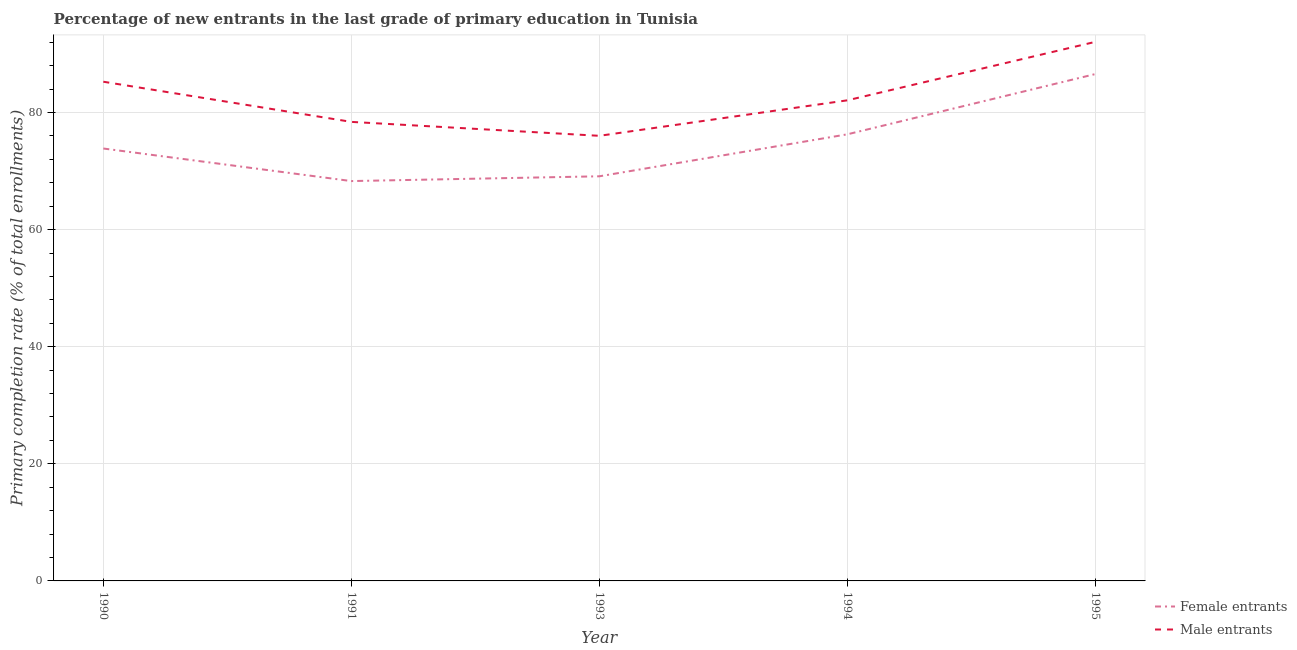Does the line corresponding to primary completion rate of female entrants intersect with the line corresponding to primary completion rate of male entrants?
Ensure brevity in your answer.  No. What is the primary completion rate of female entrants in 1993?
Offer a very short reply. 69.1. Across all years, what is the maximum primary completion rate of male entrants?
Make the answer very short. 92.07. Across all years, what is the minimum primary completion rate of female entrants?
Your response must be concise. 68.29. In which year was the primary completion rate of male entrants maximum?
Make the answer very short. 1995. In which year was the primary completion rate of female entrants minimum?
Your answer should be compact. 1991. What is the total primary completion rate of male entrants in the graph?
Provide a short and direct response. 413.82. What is the difference between the primary completion rate of female entrants in 1993 and that in 1994?
Give a very brief answer. -7.17. What is the difference between the primary completion rate of female entrants in 1994 and the primary completion rate of male entrants in 1995?
Your answer should be compact. -15.79. What is the average primary completion rate of female entrants per year?
Provide a short and direct response. 74.82. In the year 1990, what is the difference between the primary completion rate of female entrants and primary completion rate of male entrants?
Your response must be concise. -11.41. What is the ratio of the primary completion rate of female entrants in 1990 to that in 1994?
Ensure brevity in your answer.  0.97. Is the primary completion rate of male entrants in 1991 less than that in 1994?
Offer a very short reply. Yes. What is the difference between the highest and the second highest primary completion rate of female entrants?
Your answer should be compact. 10.29. What is the difference between the highest and the lowest primary completion rate of female entrants?
Provide a short and direct response. 18.28. In how many years, is the primary completion rate of female entrants greater than the average primary completion rate of female entrants taken over all years?
Your answer should be compact. 2. Is the primary completion rate of male entrants strictly greater than the primary completion rate of female entrants over the years?
Offer a terse response. Yes. Is the primary completion rate of male entrants strictly less than the primary completion rate of female entrants over the years?
Provide a succinct answer. No. How many lines are there?
Provide a short and direct response. 2. How many years are there in the graph?
Provide a succinct answer. 5. What is the difference between two consecutive major ticks on the Y-axis?
Ensure brevity in your answer.  20. Are the values on the major ticks of Y-axis written in scientific E-notation?
Your response must be concise. No. Does the graph contain any zero values?
Offer a very short reply. No. Where does the legend appear in the graph?
Your answer should be very brief. Bottom right. How are the legend labels stacked?
Your answer should be very brief. Vertical. What is the title of the graph?
Keep it short and to the point. Percentage of new entrants in the last grade of primary education in Tunisia. Does "Crop" appear as one of the legend labels in the graph?
Ensure brevity in your answer.  No. What is the label or title of the X-axis?
Your answer should be compact. Year. What is the label or title of the Y-axis?
Provide a succinct answer. Primary completion rate (% of total enrollments). What is the Primary completion rate (% of total enrollments) of Female entrants in 1990?
Keep it short and to the point. 73.85. What is the Primary completion rate (% of total enrollments) in Male entrants in 1990?
Keep it short and to the point. 85.26. What is the Primary completion rate (% of total enrollments) in Female entrants in 1991?
Offer a terse response. 68.29. What is the Primary completion rate (% of total enrollments) in Male entrants in 1991?
Offer a terse response. 78.4. What is the Primary completion rate (% of total enrollments) in Female entrants in 1993?
Give a very brief answer. 69.1. What is the Primary completion rate (% of total enrollments) of Male entrants in 1993?
Provide a short and direct response. 76.02. What is the Primary completion rate (% of total enrollments) in Female entrants in 1994?
Your answer should be very brief. 76.27. What is the Primary completion rate (% of total enrollments) in Male entrants in 1994?
Your response must be concise. 82.08. What is the Primary completion rate (% of total enrollments) of Female entrants in 1995?
Offer a very short reply. 86.57. What is the Primary completion rate (% of total enrollments) of Male entrants in 1995?
Your answer should be compact. 92.07. Across all years, what is the maximum Primary completion rate (% of total enrollments) in Female entrants?
Provide a succinct answer. 86.57. Across all years, what is the maximum Primary completion rate (% of total enrollments) of Male entrants?
Offer a terse response. 92.07. Across all years, what is the minimum Primary completion rate (% of total enrollments) in Female entrants?
Offer a very short reply. 68.29. Across all years, what is the minimum Primary completion rate (% of total enrollments) of Male entrants?
Offer a very short reply. 76.02. What is the total Primary completion rate (% of total enrollments) of Female entrants in the graph?
Your answer should be compact. 374.09. What is the total Primary completion rate (% of total enrollments) in Male entrants in the graph?
Offer a very short reply. 413.82. What is the difference between the Primary completion rate (% of total enrollments) of Female entrants in 1990 and that in 1991?
Make the answer very short. 5.56. What is the difference between the Primary completion rate (% of total enrollments) of Male entrants in 1990 and that in 1991?
Offer a very short reply. 6.86. What is the difference between the Primary completion rate (% of total enrollments) of Female entrants in 1990 and that in 1993?
Give a very brief answer. 4.75. What is the difference between the Primary completion rate (% of total enrollments) in Male entrants in 1990 and that in 1993?
Your answer should be compact. 9.24. What is the difference between the Primary completion rate (% of total enrollments) of Female entrants in 1990 and that in 1994?
Provide a succinct answer. -2.42. What is the difference between the Primary completion rate (% of total enrollments) in Male entrants in 1990 and that in 1994?
Make the answer very short. 3.17. What is the difference between the Primary completion rate (% of total enrollments) in Female entrants in 1990 and that in 1995?
Your answer should be compact. -12.72. What is the difference between the Primary completion rate (% of total enrollments) of Male entrants in 1990 and that in 1995?
Your response must be concise. -6.81. What is the difference between the Primary completion rate (% of total enrollments) of Female entrants in 1991 and that in 1993?
Give a very brief answer. -0.82. What is the difference between the Primary completion rate (% of total enrollments) of Male entrants in 1991 and that in 1993?
Ensure brevity in your answer.  2.38. What is the difference between the Primary completion rate (% of total enrollments) in Female entrants in 1991 and that in 1994?
Provide a short and direct response. -7.99. What is the difference between the Primary completion rate (% of total enrollments) in Male entrants in 1991 and that in 1994?
Your answer should be compact. -3.69. What is the difference between the Primary completion rate (% of total enrollments) of Female entrants in 1991 and that in 1995?
Make the answer very short. -18.28. What is the difference between the Primary completion rate (% of total enrollments) of Male entrants in 1991 and that in 1995?
Your response must be concise. -13.67. What is the difference between the Primary completion rate (% of total enrollments) in Female entrants in 1993 and that in 1994?
Offer a terse response. -7.17. What is the difference between the Primary completion rate (% of total enrollments) in Male entrants in 1993 and that in 1994?
Your answer should be compact. -6.06. What is the difference between the Primary completion rate (% of total enrollments) of Female entrants in 1993 and that in 1995?
Provide a succinct answer. -17.46. What is the difference between the Primary completion rate (% of total enrollments) in Male entrants in 1993 and that in 1995?
Your answer should be compact. -16.05. What is the difference between the Primary completion rate (% of total enrollments) in Female entrants in 1994 and that in 1995?
Make the answer very short. -10.29. What is the difference between the Primary completion rate (% of total enrollments) of Male entrants in 1994 and that in 1995?
Provide a succinct answer. -9.99. What is the difference between the Primary completion rate (% of total enrollments) of Female entrants in 1990 and the Primary completion rate (% of total enrollments) of Male entrants in 1991?
Offer a very short reply. -4.55. What is the difference between the Primary completion rate (% of total enrollments) of Female entrants in 1990 and the Primary completion rate (% of total enrollments) of Male entrants in 1993?
Your response must be concise. -2.17. What is the difference between the Primary completion rate (% of total enrollments) in Female entrants in 1990 and the Primary completion rate (% of total enrollments) in Male entrants in 1994?
Your response must be concise. -8.23. What is the difference between the Primary completion rate (% of total enrollments) in Female entrants in 1990 and the Primary completion rate (% of total enrollments) in Male entrants in 1995?
Provide a short and direct response. -18.22. What is the difference between the Primary completion rate (% of total enrollments) in Female entrants in 1991 and the Primary completion rate (% of total enrollments) in Male entrants in 1993?
Provide a succinct answer. -7.73. What is the difference between the Primary completion rate (% of total enrollments) of Female entrants in 1991 and the Primary completion rate (% of total enrollments) of Male entrants in 1994?
Keep it short and to the point. -13.79. What is the difference between the Primary completion rate (% of total enrollments) of Female entrants in 1991 and the Primary completion rate (% of total enrollments) of Male entrants in 1995?
Give a very brief answer. -23.78. What is the difference between the Primary completion rate (% of total enrollments) of Female entrants in 1993 and the Primary completion rate (% of total enrollments) of Male entrants in 1994?
Your answer should be very brief. -12.98. What is the difference between the Primary completion rate (% of total enrollments) in Female entrants in 1993 and the Primary completion rate (% of total enrollments) in Male entrants in 1995?
Give a very brief answer. -22.96. What is the difference between the Primary completion rate (% of total enrollments) of Female entrants in 1994 and the Primary completion rate (% of total enrollments) of Male entrants in 1995?
Make the answer very short. -15.79. What is the average Primary completion rate (% of total enrollments) in Female entrants per year?
Make the answer very short. 74.82. What is the average Primary completion rate (% of total enrollments) of Male entrants per year?
Keep it short and to the point. 82.76. In the year 1990, what is the difference between the Primary completion rate (% of total enrollments) in Female entrants and Primary completion rate (% of total enrollments) in Male entrants?
Your answer should be very brief. -11.41. In the year 1991, what is the difference between the Primary completion rate (% of total enrollments) of Female entrants and Primary completion rate (% of total enrollments) of Male entrants?
Provide a short and direct response. -10.11. In the year 1993, what is the difference between the Primary completion rate (% of total enrollments) in Female entrants and Primary completion rate (% of total enrollments) in Male entrants?
Make the answer very short. -6.91. In the year 1994, what is the difference between the Primary completion rate (% of total enrollments) of Female entrants and Primary completion rate (% of total enrollments) of Male entrants?
Make the answer very short. -5.81. In the year 1995, what is the difference between the Primary completion rate (% of total enrollments) in Female entrants and Primary completion rate (% of total enrollments) in Male entrants?
Give a very brief answer. -5.5. What is the ratio of the Primary completion rate (% of total enrollments) in Female entrants in 1990 to that in 1991?
Make the answer very short. 1.08. What is the ratio of the Primary completion rate (% of total enrollments) of Male entrants in 1990 to that in 1991?
Provide a succinct answer. 1.09. What is the ratio of the Primary completion rate (% of total enrollments) of Female entrants in 1990 to that in 1993?
Your response must be concise. 1.07. What is the ratio of the Primary completion rate (% of total enrollments) in Male entrants in 1990 to that in 1993?
Your response must be concise. 1.12. What is the ratio of the Primary completion rate (% of total enrollments) of Female entrants in 1990 to that in 1994?
Your response must be concise. 0.97. What is the ratio of the Primary completion rate (% of total enrollments) in Male entrants in 1990 to that in 1994?
Your response must be concise. 1.04. What is the ratio of the Primary completion rate (% of total enrollments) of Female entrants in 1990 to that in 1995?
Provide a succinct answer. 0.85. What is the ratio of the Primary completion rate (% of total enrollments) in Male entrants in 1990 to that in 1995?
Ensure brevity in your answer.  0.93. What is the ratio of the Primary completion rate (% of total enrollments) of Male entrants in 1991 to that in 1993?
Keep it short and to the point. 1.03. What is the ratio of the Primary completion rate (% of total enrollments) in Female entrants in 1991 to that in 1994?
Your answer should be compact. 0.9. What is the ratio of the Primary completion rate (% of total enrollments) of Male entrants in 1991 to that in 1994?
Your answer should be compact. 0.96. What is the ratio of the Primary completion rate (% of total enrollments) of Female entrants in 1991 to that in 1995?
Make the answer very short. 0.79. What is the ratio of the Primary completion rate (% of total enrollments) of Male entrants in 1991 to that in 1995?
Make the answer very short. 0.85. What is the ratio of the Primary completion rate (% of total enrollments) in Female entrants in 1993 to that in 1994?
Make the answer very short. 0.91. What is the ratio of the Primary completion rate (% of total enrollments) of Male entrants in 1993 to that in 1994?
Provide a succinct answer. 0.93. What is the ratio of the Primary completion rate (% of total enrollments) in Female entrants in 1993 to that in 1995?
Make the answer very short. 0.8. What is the ratio of the Primary completion rate (% of total enrollments) in Male entrants in 1993 to that in 1995?
Give a very brief answer. 0.83. What is the ratio of the Primary completion rate (% of total enrollments) in Female entrants in 1994 to that in 1995?
Keep it short and to the point. 0.88. What is the ratio of the Primary completion rate (% of total enrollments) in Male entrants in 1994 to that in 1995?
Offer a very short reply. 0.89. What is the difference between the highest and the second highest Primary completion rate (% of total enrollments) in Female entrants?
Provide a short and direct response. 10.29. What is the difference between the highest and the second highest Primary completion rate (% of total enrollments) in Male entrants?
Your response must be concise. 6.81. What is the difference between the highest and the lowest Primary completion rate (% of total enrollments) of Female entrants?
Your response must be concise. 18.28. What is the difference between the highest and the lowest Primary completion rate (% of total enrollments) of Male entrants?
Provide a short and direct response. 16.05. 